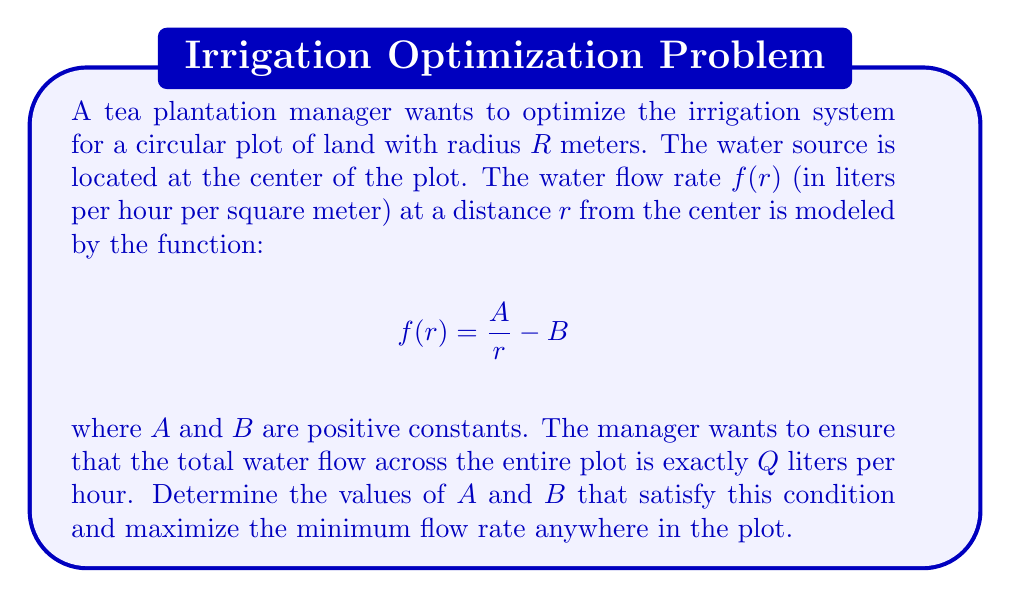Teach me how to tackle this problem. Let's approach this problem step by step:

1) First, we need to calculate the total water flow across the entire plot. This can be done by integrating the flow rate function over the circular area:

   $$Q = \int_0^R \int_0^{2\pi} f(r) \cdot r \, d\theta \, dr = 2\pi \int_0^R (A - Br) \, dr$$

2) Solving this integral:

   $$Q = 2\pi \left[Ar - \frac{Br^2}{2}\right]_0^R = 2\pi \left(AR - \frac{BR^2}{2}\right)$$

3) Now, we want to maximize the minimum flow rate. The flow rate decreases as $r$ increases, so the minimum flow rate occurs at $r = R$:

   $$f_{min} = f(R) = \frac{A}{R} - B$$

4) We have two equations and two unknowns. From the first equation:

   $$A = \frac{Q}{2\pi R} + \frac{BR}{2}$$

5) Substituting this into the equation for $f_{min}$:

   $$f_{min} = \frac{Q}{2\pi R^2} + \frac{B}{2} - B = \frac{Q}{2\pi R^2} - \frac{B}{2}$$

6) To maximize $f_{min}$, we need to maximize $\frac{Q}{2\pi R^2} - \frac{B}{2}$. Since $\frac{Q}{2\pi R^2}$ is constant, this is equivalent to minimizing $B$.

7) The smallest possible value for $B$ is when $A = BR$, which ensures that $f(r)$ is always positive. So:

   $$\frac{Q}{2\pi R} + \frac{BR}{2} = BR$$

8) Solving for $B$:

   $$B = \frac{Q}{\pi R^3}$$

9) And consequently:

   $$A = \frac{QR}{\pi R^3} = \frac{Q}{\pi R^2}$$

These values of $A$ and $B$ will satisfy the total flow condition and maximize the minimum flow rate.
Answer: The optimal values are:

$$A = \frac{Q}{\pi R^2}$$ and $$B = \frac{Q}{\pi R^3}$$

where $Q$ is the total desired flow rate in liters per hour and $R$ is the radius of the circular plot in meters. 